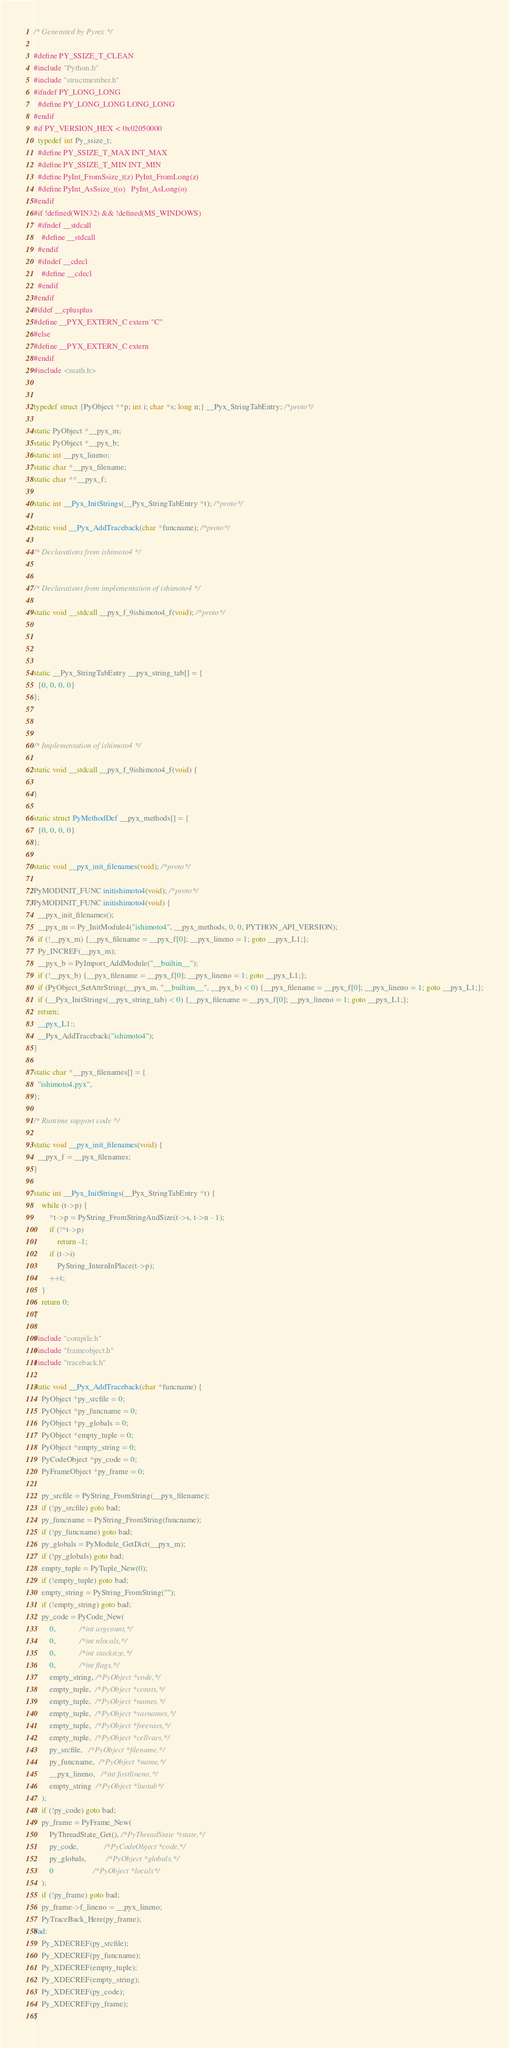Convert code to text. <code><loc_0><loc_0><loc_500><loc_500><_C_>/* Generated by Pyrex */

#define PY_SSIZE_T_CLEAN
#include "Python.h"
#include "structmember.h"
#ifndef PY_LONG_LONG
  #define PY_LONG_LONG LONG_LONG
#endif
#if PY_VERSION_HEX < 0x02050000
  typedef int Py_ssize_t;
  #define PY_SSIZE_T_MAX INT_MAX
  #define PY_SSIZE_T_MIN INT_MIN
  #define PyInt_FromSsize_t(z) PyInt_FromLong(z)
  #define PyInt_AsSsize_t(o)	PyInt_AsLong(o)
#endif
#if !defined(WIN32) && !defined(MS_WINDOWS)
  #ifndef __stdcall
    #define __stdcall
  #endif
  #ifndef __cdecl
    #define __cdecl
  #endif
#endif
#ifdef __cplusplus
#define __PYX_EXTERN_C extern "C"
#else
#define __PYX_EXTERN_C extern
#endif
#include <math.h>


typedef struct {PyObject **p; int i; char *s; long n;} __Pyx_StringTabEntry; /*proto*/

static PyObject *__pyx_m;
static PyObject *__pyx_b;
static int __pyx_lineno;
static char *__pyx_filename;
static char **__pyx_f;

static int __Pyx_InitStrings(__Pyx_StringTabEntry *t); /*proto*/

static void __Pyx_AddTraceback(char *funcname); /*proto*/

/* Declarations from ishimoto4 */


/* Declarations from implementation of ishimoto4 */

static void __stdcall __pyx_f_9ishimoto4_f(void); /*proto*/




static __Pyx_StringTabEntry __pyx_string_tab[] = {
  {0, 0, 0, 0}
};



/* Implementation of ishimoto4 */

static void __stdcall __pyx_f_9ishimoto4_f(void) {

}

static struct PyMethodDef __pyx_methods[] = {
  {0, 0, 0, 0}
};

static void __pyx_init_filenames(void); /*proto*/

PyMODINIT_FUNC initishimoto4(void); /*proto*/
PyMODINIT_FUNC initishimoto4(void) {
  __pyx_init_filenames();
  __pyx_m = Py_InitModule4("ishimoto4", __pyx_methods, 0, 0, PYTHON_API_VERSION);
  if (!__pyx_m) {__pyx_filename = __pyx_f[0]; __pyx_lineno = 1; goto __pyx_L1;};
  Py_INCREF(__pyx_m);
  __pyx_b = PyImport_AddModule("__builtin__");
  if (!__pyx_b) {__pyx_filename = __pyx_f[0]; __pyx_lineno = 1; goto __pyx_L1;};
  if (PyObject_SetAttrString(__pyx_m, "__builtins__", __pyx_b) < 0) {__pyx_filename = __pyx_f[0]; __pyx_lineno = 1; goto __pyx_L1;};
  if (__Pyx_InitStrings(__pyx_string_tab) < 0) {__pyx_filename = __pyx_f[0]; __pyx_lineno = 1; goto __pyx_L1;};
  return;
  __pyx_L1:;
  __Pyx_AddTraceback("ishimoto4");
}

static char *__pyx_filenames[] = {
  "ishimoto4.pyx",
};

/* Runtime support code */

static void __pyx_init_filenames(void) {
  __pyx_f = __pyx_filenames;
}

static int __Pyx_InitStrings(__Pyx_StringTabEntry *t) {
	while (t->p) {
		*t->p = PyString_FromStringAndSize(t->s, t->n - 1);
		if (!*t->p)
			return -1;
		if (t->i)
			PyString_InternInPlace(t->p);
		++t;
	}
	return 0;
}

#include "compile.h"
#include "frameobject.h"
#include "traceback.h"

static void __Pyx_AddTraceback(char *funcname) {
	PyObject *py_srcfile = 0;
	PyObject *py_funcname = 0;
	PyObject *py_globals = 0;
	PyObject *empty_tuple = 0;
	PyObject *empty_string = 0;
	PyCodeObject *py_code = 0;
	PyFrameObject *py_frame = 0;
	
	py_srcfile = PyString_FromString(__pyx_filename);
	if (!py_srcfile) goto bad;
	py_funcname = PyString_FromString(funcname);
	if (!py_funcname) goto bad;
	py_globals = PyModule_GetDict(__pyx_m);
	if (!py_globals) goto bad;
	empty_tuple = PyTuple_New(0);
	if (!empty_tuple) goto bad;
	empty_string = PyString_FromString("");
	if (!empty_string) goto bad;
	py_code = PyCode_New(
		0,            /*int argcount,*/
		0,            /*int nlocals,*/
		0,            /*int stacksize,*/
		0,            /*int flags,*/
		empty_string, /*PyObject *code,*/
		empty_tuple,  /*PyObject *consts,*/
		empty_tuple,  /*PyObject *names,*/
		empty_tuple,  /*PyObject *varnames,*/
		empty_tuple,  /*PyObject *freevars,*/
		empty_tuple,  /*PyObject *cellvars,*/
		py_srcfile,   /*PyObject *filename,*/
		py_funcname,  /*PyObject *name,*/
		__pyx_lineno,   /*int firstlineno,*/
		empty_string  /*PyObject *lnotab*/
	);
	if (!py_code) goto bad;
	py_frame = PyFrame_New(
		PyThreadState_Get(), /*PyThreadState *tstate,*/
		py_code,             /*PyCodeObject *code,*/
		py_globals,          /*PyObject *globals,*/
		0                    /*PyObject *locals*/
	);
	if (!py_frame) goto bad;
	py_frame->f_lineno = __pyx_lineno;
	PyTraceBack_Here(py_frame);
bad:
	Py_XDECREF(py_srcfile);
	Py_XDECREF(py_funcname);
	Py_XDECREF(empty_tuple);
	Py_XDECREF(empty_string);
	Py_XDECREF(py_code);
	Py_XDECREF(py_frame);
}
</code> 